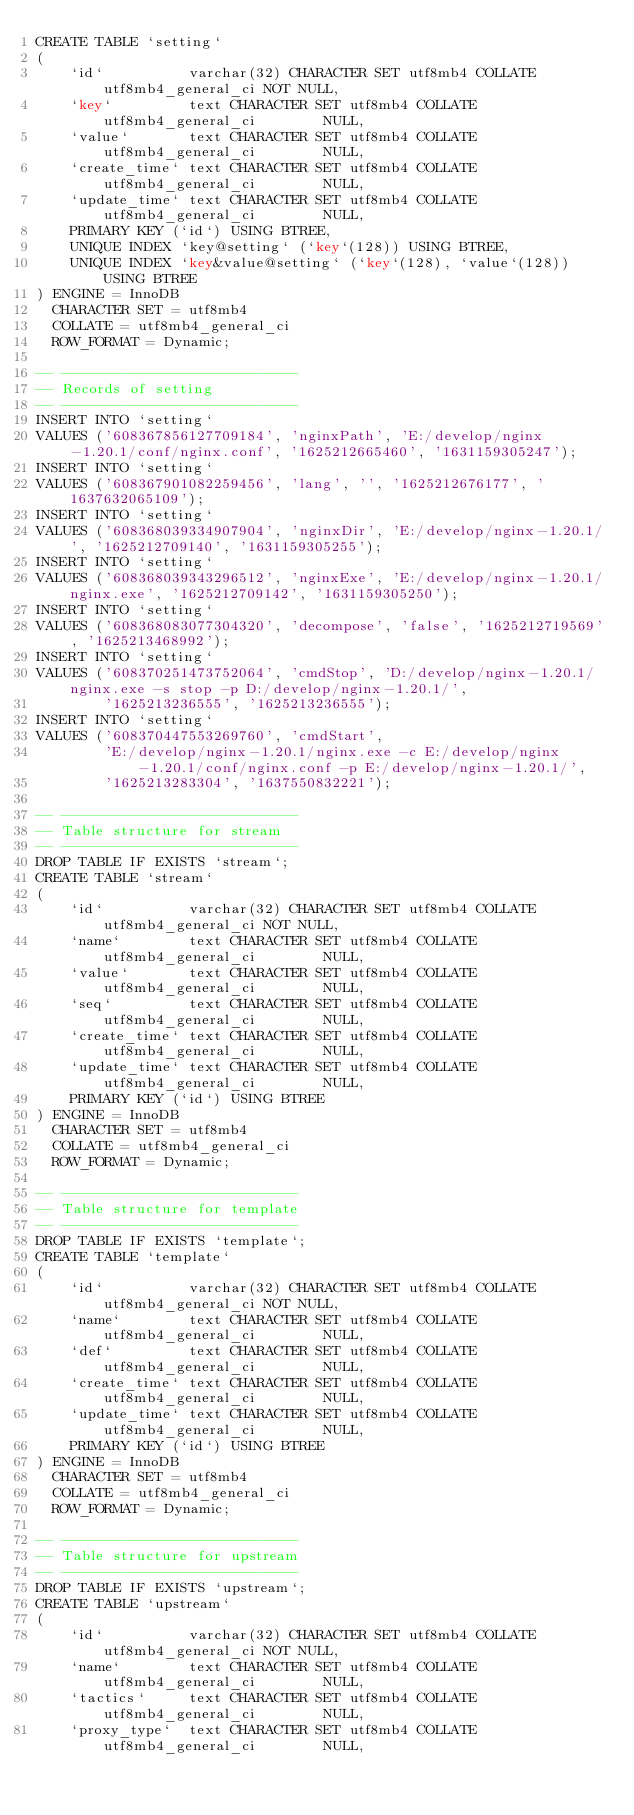Convert code to text. <code><loc_0><loc_0><loc_500><loc_500><_SQL_>CREATE TABLE `setting`
(
    `id`          varchar(32) CHARACTER SET utf8mb4 COLLATE utf8mb4_general_ci NOT NULL,
    `key`         text CHARACTER SET utf8mb4 COLLATE utf8mb4_general_ci        NULL,
    `value`       text CHARACTER SET utf8mb4 COLLATE utf8mb4_general_ci        NULL,
    `create_time` text CHARACTER SET utf8mb4 COLLATE utf8mb4_general_ci        NULL,
    `update_time` text CHARACTER SET utf8mb4 COLLATE utf8mb4_general_ci        NULL,
    PRIMARY KEY (`id`) USING BTREE,
    UNIQUE INDEX `key@setting` (`key`(128)) USING BTREE,
    UNIQUE INDEX `key&value@setting` (`key`(128), `value`(128)) USING BTREE
) ENGINE = InnoDB
  CHARACTER SET = utf8mb4
  COLLATE = utf8mb4_general_ci
  ROW_FORMAT = Dynamic;

-- ----------------------------
-- Records of setting
-- ----------------------------
INSERT INTO `setting`
VALUES ('608367856127709184', 'nginxPath', 'E:/develop/nginx-1.20.1/conf/nginx.conf', '1625212665460', '1631159305247');
INSERT INTO `setting`
VALUES ('608367901082259456', 'lang', '', '1625212676177', '1637632065109');
INSERT INTO `setting`
VALUES ('608368039334907904', 'nginxDir', 'E:/develop/nginx-1.20.1/', '1625212709140', '1631159305255');
INSERT INTO `setting`
VALUES ('608368039343296512', 'nginxExe', 'E:/develop/nginx-1.20.1/nginx.exe', '1625212709142', '1631159305250');
INSERT INTO `setting`
VALUES ('608368083077304320', 'decompose', 'false', '1625212719569', '1625213468992');
INSERT INTO `setting`
VALUES ('608370251473752064', 'cmdStop', 'D:/develop/nginx-1.20.1/nginx.exe -s stop -p D:/develop/nginx-1.20.1/',
        '1625213236555', '1625213236555');
INSERT INTO `setting`
VALUES ('608370447553269760', 'cmdStart',
        'E:/develop/nginx-1.20.1/nginx.exe -c E:/develop/nginx-1.20.1/conf/nginx.conf -p E:/develop/nginx-1.20.1/',
        '1625213283304', '1637550832221');

-- ----------------------------
-- Table structure for stream
-- ----------------------------
DROP TABLE IF EXISTS `stream`;
CREATE TABLE `stream`
(
    `id`          varchar(32) CHARACTER SET utf8mb4 COLLATE utf8mb4_general_ci NOT NULL,
    `name`        text CHARACTER SET utf8mb4 COLLATE utf8mb4_general_ci        NULL,
    `value`       text CHARACTER SET utf8mb4 COLLATE utf8mb4_general_ci        NULL,
    `seq`         text CHARACTER SET utf8mb4 COLLATE utf8mb4_general_ci        NULL,
    `create_time` text CHARACTER SET utf8mb4 COLLATE utf8mb4_general_ci        NULL,
    `update_time` text CHARACTER SET utf8mb4 COLLATE utf8mb4_general_ci        NULL,
    PRIMARY KEY (`id`) USING BTREE
) ENGINE = InnoDB
  CHARACTER SET = utf8mb4
  COLLATE = utf8mb4_general_ci
  ROW_FORMAT = Dynamic;

-- ----------------------------
-- Table structure for template
-- ----------------------------
DROP TABLE IF EXISTS `template`;
CREATE TABLE `template`
(
    `id`          varchar(32) CHARACTER SET utf8mb4 COLLATE utf8mb4_general_ci NOT NULL,
    `name`        text CHARACTER SET utf8mb4 COLLATE utf8mb4_general_ci        NULL,
    `def`         text CHARACTER SET utf8mb4 COLLATE utf8mb4_general_ci        NULL,
    `create_time` text CHARACTER SET utf8mb4 COLLATE utf8mb4_general_ci        NULL,
    `update_time` text CHARACTER SET utf8mb4 COLLATE utf8mb4_general_ci        NULL,
    PRIMARY KEY (`id`) USING BTREE
) ENGINE = InnoDB
  CHARACTER SET = utf8mb4
  COLLATE = utf8mb4_general_ci
  ROW_FORMAT = Dynamic;

-- ----------------------------
-- Table structure for upstream
-- ----------------------------
DROP TABLE IF EXISTS `upstream`;
CREATE TABLE `upstream`
(
    `id`          varchar(32) CHARACTER SET utf8mb4 COLLATE utf8mb4_general_ci NOT NULL,
    `name`        text CHARACTER SET utf8mb4 COLLATE utf8mb4_general_ci        NULL,
    `tactics`     text CHARACTER SET utf8mb4 COLLATE utf8mb4_general_ci        NULL,
    `proxy_type`  text CHARACTER SET utf8mb4 COLLATE utf8mb4_general_ci        NULL,</code> 